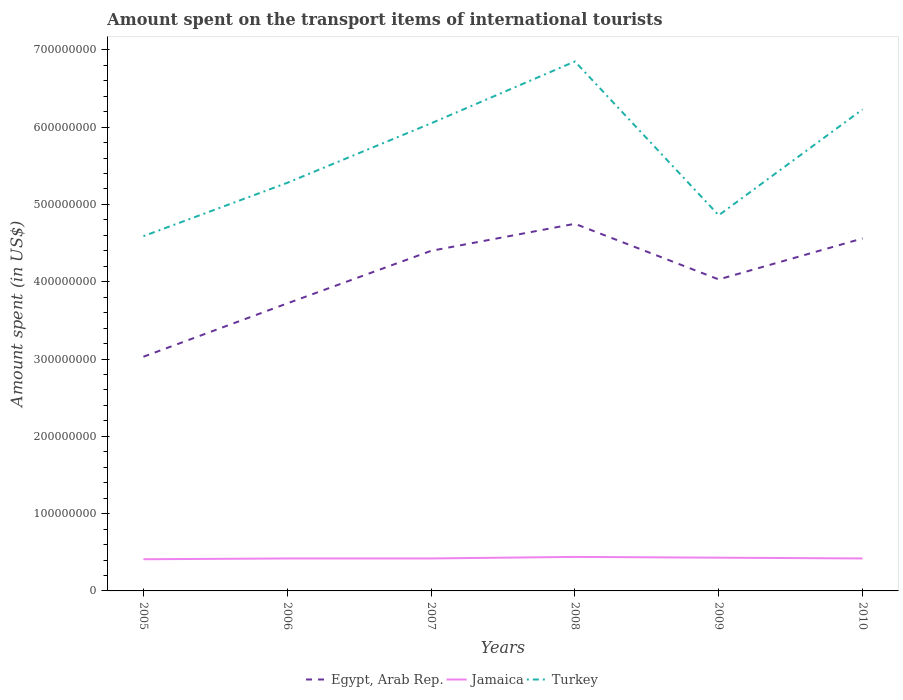How many different coloured lines are there?
Offer a terse response. 3. Across all years, what is the maximum amount spent on the transport items of international tourists in Jamaica?
Provide a succinct answer. 4.10e+07. In which year was the amount spent on the transport items of international tourists in Jamaica maximum?
Ensure brevity in your answer.  2005. What is the total amount spent on the transport items of international tourists in Jamaica in the graph?
Offer a terse response. 0. What is the difference between the highest and the second highest amount spent on the transport items of international tourists in Egypt, Arab Rep.?
Provide a succinct answer. 1.72e+08. What is the difference between the highest and the lowest amount spent on the transport items of international tourists in Egypt, Arab Rep.?
Your answer should be very brief. 3. How many years are there in the graph?
Make the answer very short. 6. What is the difference between two consecutive major ticks on the Y-axis?
Ensure brevity in your answer.  1.00e+08. Does the graph contain grids?
Your answer should be compact. No. How many legend labels are there?
Keep it short and to the point. 3. How are the legend labels stacked?
Keep it short and to the point. Horizontal. What is the title of the graph?
Ensure brevity in your answer.  Amount spent on the transport items of international tourists. What is the label or title of the X-axis?
Provide a succinct answer. Years. What is the label or title of the Y-axis?
Give a very brief answer. Amount spent (in US$). What is the Amount spent (in US$) of Egypt, Arab Rep. in 2005?
Keep it short and to the point. 3.03e+08. What is the Amount spent (in US$) of Jamaica in 2005?
Your answer should be very brief. 4.10e+07. What is the Amount spent (in US$) of Turkey in 2005?
Your answer should be very brief. 4.59e+08. What is the Amount spent (in US$) of Egypt, Arab Rep. in 2006?
Provide a succinct answer. 3.72e+08. What is the Amount spent (in US$) in Jamaica in 2006?
Make the answer very short. 4.20e+07. What is the Amount spent (in US$) of Turkey in 2006?
Make the answer very short. 5.28e+08. What is the Amount spent (in US$) of Egypt, Arab Rep. in 2007?
Provide a succinct answer. 4.40e+08. What is the Amount spent (in US$) in Jamaica in 2007?
Make the answer very short. 4.20e+07. What is the Amount spent (in US$) of Turkey in 2007?
Your response must be concise. 6.05e+08. What is the Amount spent (in US$) in Egypt, Arab Rep. in 2008?
Make the answer very short. 4.75e+08. What is the Amount spent (in US$) of Jamaica in 2008?
Your answer should be compact. 4.40e+07. What is the Amount spent (in US$) in Turkey in 2008?
Offer a very short reply. 6.85e+08. What is the Amount spent (in US$) of Egypt, Arab Rep. in 2009?
Give a very brief answer. 4.03e+08. What is the Amount spent (in US$) in Jamaica in 2009?
Your answer should be very brief. 4.30e+07. What is the Amount spent (in US$) in Turkey in 2009?
Provide a short and direct response. 4.86e+08. What is the Amount spent (in US$) of Egypt, Arab Rep. in 2010?
Give a very brief answer. 4.56e+08. What is the Amount spent (in US$) of Jamaica in 2010?
Offer a very short reply. 4.20e+07. What is the Amount spent (in US$) in Turkey in 2010?
Your answer should be very brief. 6.23e+08. Across all years, what is the maximum Amount spent (in US$) in Egypt, Arab Rep.?
Your answer should be compact. 4.75e+08. Across all years, what is the maximum Amount spent (in US$) in Jamaica?
Your answer should be compact. 4.40e+07. Across all years, what is the maximum Amount spent (in US$) of Turkey?
Ensure brevity in your answer.  6.85e+08. Across all years, what is the minimum Amount spent (in US$) in Egypt, Arab Rep.?
Your response must be concise. 3.03e+08. Across all years, what is the minimum Amount spent (in US$) of Jamaica?
Ensure brevity in your answer.  4.10e+07. Across all years, what is the minimum Amount spent (in US$) in Turkey?
Your answer should be very brief. 4.59e+08. What is the total Amount spent (in US$) of Egypt, Arab Rep. in the graph?
Offer a very short reply. 2.45e+09. What is the total Amount spent (in US$) of Jamaica in the graph?
Provide a short and direct response. 2.54e+08. What is the total Amount spent (in US$) of Turkey in the graph?
Provide a short and direct response. 3.39e+09. What is the difference between the Amount spent (in US$) of Egypt, Arab Rep. in 2005 and that in 2006?
Your response must be concise. -6.90e+07. What is the difference between the Amount spent (in US$) in Turkey in 2005 and that in 2006?
Give a very brief answer. -6.90e+07. What is the difference between the Amount spent (in US$) of Egypt, Arab Rep. in 2005 and that in 2007?
Provide a short and direct response. -1.37e+08. What is the difference between the Amount spent (in US$) in Turkey in 2005 and that in 2007?
Offer a very short reply. -1.46e+08. What is the difference between the Amount spent (in US$) in Egypt, Arab Rep. in 2005 and that in 2008?
Offer a very short reply. -1.72e+08. What is the difference between the Amount spent (in US$) in Turkey in 2005 and that in 2008?
Provide a succinct answer. -2.26e+08. What is the difference between the Amount spent (in US$) in Egypt, Arab Rep. in 2005 and that in 2009?
Ensure brevity in your answer.  -1.00e+08. What is the difference between the Amount spent (in US$) in Turkey in 2005 and that in 2009?
Make the answer very short. -2.70e+07. What is the difference between the Amount spent (in US$) of Egypt, Arab Rep. in 2005 and that in 2010?
Give a very brief answer. -1.53e+08. What is the difference between the Amount spent (in US$) of Turkey in 2005 and that in 2010?
Your answer should be very brief. -1.64e+08. What is the difference between the Amount spent (in US$) in Egypt, Arab Rep. in 2006 and that in 2007?
Keep it short and to the point. -6.80e+07. What is the difference between the Amount spent (in US$) of Turkey in 2006 and that in 2007?
Ensure brevity in your answer.  -7.70e+07. What is the difference between the Amount spent (in US$) of Egypt, Arab Rep. in 2006 and that in 2008?
Offer a terse response. -1.03e+08. What is the difference between the Amount spent (in US$) of Jamaica in 2006 and that in 2008?
Provide a succinct answer. -2.00e+06. What is the difference between the Amount spent (in US$) in Turkey in 2006 and that in 2008?
Offer a very short reply. -1.57e+08. What is the difference between the Amount spent (in US$) in Egypt, Arab Rep. in 2006 and that in 2009?
Offer a very short reply. -3.10e+07. What is the difference between the Amount spent (in US$) of Turkey in 2006 and that in 2009?
Your answer should be compact. 4.20e+07. What is the difference between the Amount spent (in US$) in Egypt, Arab Rep. in 2006 and that in 2010?
Offer a very short reply. -8.40e+07. What is the difference between the Amount spent (in US$) in Jamaica in 2006 and that in 2010?
Your answer should be very brief. 0. What is the difference between the Amount spent (in US$) in Turkey in 2006 and that in 2010?
Provide a succinct answer. -9.50e+07. What is the difference between the Amount spent (in US$) of Egypt, Arab Rep. in 2007 and that in 2008?
Ensure brevity in your answer.  -3.50e+07. What is the difference between the Amount spent (in US$) of Turkey in 2007 and that in 2008?
Ensure brevity in your answer.  -8.00e+07. What is the difference between the Amount spent (in US$) of Egypt, Arab Rep. in 2007 and that in 2009?
Provide a short and direct response. 3.70e+07. What is the difference between the Amount spent (in US$) in Jamaica in 2007 and that in 2009?
Give a very brief answer. -1.00e+06. What is the difference between the Amount spent (in US$) of Turkey in 2007 and that in 2009?
Offer a terse response. 1.19e+08. What is the difference between the Amount spent (in US$) in Egypt, Arab Rep. in 2007 and that in 2010?
Keep it short and to the point. -1.60e+07. What is the difference between the Amount spent (in US$) of Jamaica in 2007 and that in 2010?
Your response must be concise. 0. What is the difference between the Amount spent (in US$) in Turkey in 2007 and that in 2010?
Your answer should be very brief. -1.80e+07. What is the difference between the Amount spent (in US$) of Egypt, Arab Rep. in 2008 and that in 2009?
Your answer should be very brief. 7.20e+07. What is the difference between the Amount spent (in US$) in Turkey in 2008 and that in 2009?
Ensure brevity in your answer.  1.99e+08. What is the difference between the Amount spent (in US$) of Egypt, Arab Rep. in 2008 and that in 2010?
Offer a very short reply. 1.90e+07. What is the difference between the Amount spent (in US$) of Jamaica in 2008 and that in 2010?
Your answer should be very brief. 2.00e+06. What is the difference between the Amount spent (in US$) in Turkey in 2008 and that in 2010?
Give a very brief answer. 6.20e+07. What is the difference between the Amount spent (in US$) of Egypt, Arab Rep. in 2009 and that in 2010?
Offer a very short reply. -5.30e+07. What is the difference between the Amount spent (in US$) of Turkey in 2009 and that in 2010?
Provide a succinct answer. -1.37e+08. What is the difference between the Amount spent (in US$) of Egypt, Arab Rep. in 2005 and the Amount spent (in US$) of Jamaica in 2006?
Keep it short and to the point. 2.61e+08. What is the difference between the Amount spent (in US$) in Egypt, Arab Rep. in 2005 and the Amount spent (in US$) in Turkey in 2006?
Offer a terse response. -2.25e+08. What is the difference between the Amount spent (in US$) of Jamaica in 2005 and the Amount spent (in US$) of Turkey in 2006?
Your response must be concise. -4.87e+08. What is the difference between the Amount spent (in US$) in Egypt, Arab Rep. in 2005 and the Amount spent (in US$) in Jamaica in 2007?
Offer a very short reply. 2.61e+08. What is the difference between the Amount spent (in US$) of Egypt, Arab Rep. in 2005 and the Amount spent (in US$) of Turkey in 2007?
Your response must be concise. -3.02e+08. What is the difference between the Amount spent (in US$) in Jamaica in 2005 and the Amount spent (in US$) in Turkey in 2007?
Your answer should be very brief. -5.64e+08. What is the difference between the Amount spent (in US$) of Egypt, Arab Rep. in 2005 and the Amount spent (in US$) of Jamaica in 2008?
Your answer should be very brief. 2.59e+08. What is the difference between the Amount spent (in US$) in Egypt, Arab Rep. in 2005 and the Amount spent (in US$) in Turkey in 2008?
Provide a succinct answer. -3.82e+08. What is the difference between the Amount spent (in US$) of Jamaica in 2005 and the Amount spent (in US$) of Turkey in 2008?
Give a very brief answer. -6.44e+08. What is the difference between the Amount spent (in US$) of Egypt, Arab Rep. in 2005 and the Amount spent (in US$) of Jamaica in 2009?
Offer a terse response. 2.60e+08. What is the difference between the Amount spent (in US$) of Egypt, Arab Rep. in 2005 and the Amount spent (in US$) of Turkey in 2009?
Ensure brevity in your answer.  -1.83e+08. What is the difference between the Amount spent (in US$) of Jamaica in 2005 and the Amount spent (in US$) of Turkey in 2009?
Make the answer very short. -4.45e+08. What is the difference between the Amount spent (in US$) of Egypt, Arab Rep. in 2005 and the Amount spent (in US$) of Jamaica in 2010?
Your answer should be compact. 2.61e+08. What is the difference between the Amount spent (in US$) in Egypt, Arab Rep. in 2005 and the Amount spent (in US$) in Turkey in 2010?
Provide a succinct answer. -3.20e+08. What is the difference between the Amount spent (in US$) of Jamaica in 2005 and the Amount spent (in US$) of Turkey in 2010?
Offer a terse response. -5.82e+08. What is the difference between the Amount spent (in US$) in Egypt, Arab Rep. in 2006 and the Amount spent (in US$) in Jamaica in 2007?
Provide a short and direct response. 3.30e+08. What is the difference between the Amount spent (in US$) of Egypt, Arab Rep. in 2006 and the Amount spent (in US$) of Turkey in 2007?
Your answer should be compact. -2.33e+08. What is the difference between the Amount spent (in US$) of Jamaica in 2006 and the Amount spent (in US$) of Turkey in 2007?
Provide a short and direct response. -5.63e+08. What is the difference between the Amount spent (in US$) in Egypt, Arab Rep. in 2006 and the Amount spent (in US$) in Jamaica in 2008?
Give a very brief answer. 3.28e+08. What is the difference between the Amount spent (in US$) of Egypt, Arab Rep. in 2006 and the Amount spent (in US$) of Turkey in 2008?
Offer a terse response. -3.13e+08. What is the difference between the Amount spent (in US$) of Jamaica in 2006 and the Amount spent (in US$) of Turkey in 2008?
Provide a short and direct response. -6.43e+08. What is the difference between the Amount spent (in US$) in Egypt, Arab Rep. in 2006 and the Amount spent (in US$) in Jamaica in 2009?
Offer a very short reply. 3.29e+08. What is the difference between the Amount spent (in US$) of Egypt, Arab Rep. in 2006 and the Amount spent (in US$) of Turkey in 2009?
Ensure brevity in your answer.  -1.14e+08. What is the difference between the Amount spent (in US$) in Jamaica in 2006 and the Amount spent (in US$) in Turkey in 2009?
Your response must be concise. -4.44e+08. What is the difference between the Amount spent (in US$) in Egypt, Arab Rep. in 2006 and the Amount spent (in US$) in Jamaica in 2010?
Keep it short and to the point. 3.30e+08. What is the difference between the Amount spent (in US$) of Egypt, Arab Rep. in 2006 and the Amount spent (in US$) of Turkey in 2010?
Provide a succinct answer. -2.51e+08. What is the difference between the Amount spent (in US$) in Jamaica in 2006 and the Amount spent (in US$) in Turkey in 2010?
Your answer should be compact. -5.81e+08. What is the difference between the Amount spent (in US$) in Egypt, Arab Rep. in 2007 and the Amount spent (in US$) in Jamaica in 2008?
Your answer should be compact. 3.96e+08. What is the difference between the Amount spent (in US$) in Egypt, Arab Rep. in 2007 and the Amount spent (in US$) in Turkey in 2008?
Your response must be concise. -2.45e+08. What is the difference between the Amount spent (in US$) in Jamaica in 2007 and the Amount spent (in US$) in Turkey in 2008?
Offer a very short reply. -6.43e+08. What is the difference between the Amount spent (in US$) in Egypt, Arab Rep. in 2007 and the Amount spent (in US$) in Jamaica in 2009?
Give a very brief answer. 3.97e+08. What is the difference between the Amount spent (in US$) in Egypt, Arab Rep. in 2007 and the Amount spent (in US$) in Turkey in 2009?
Offer a very short reply. -4.60e+07. What is the difference between the Amount spent (in US$) in Jamaica in 2007 and the Amount spent (in US$) in Turkey in 2009?
Your answer should be very brief. -4.44e+08. What is the difference between the Amount spent (in US$) of Egypt, Arab Rep. in 2007 and the Amount spent (in US$) of Jamaica in 2010?
Make the answer very short. 3.98e+08. What is the difference between the Amount spent (in US$) of Egypt, Arab Rep. in 2007 and the Amount spent (in US$) of Turkey in 2010?
Make the answer very short. -1.83e+08. What is the difference between the Amount spent (in US$) in Jamaica in 2007 and the Amount spent (in US$) in Turkey in 2010?
Your response must be concise. -5.81e+08. What is the difference between the Amount spent (in US$) of Egypt, Arab Rep. in 2008 and the Amount spent (in US$) of Jamaica in 2009?
Provide a short and direct response. 4.32e+08. What is the difference between the Amount spent (in US$) in Egypt, Arab Rep. in 2008 and the Amount spent (in US$) in Turkey in 2009?
Make the answer very short. -1.10e+07. What is the difference between the Amount spent (in US$) in Jamaica in 2008 and the Amount spent (in US$) in Turkey in 2009?
Make the answer very short. -4.42e+08. What is the difference between the Amount spent (in US$) of Egypt, Arab Rep. in 2008 and the Amount spent (in US$) of Jamaica in 2010?
Provide a short and direct response. 4.33e+08. What is the difference between the Amount spent (in US$) in Egypt, Arab Rep. in 2008 and the Amount spent (in US$) in Turkey in 2010?
Give a very brief answer. -1.48e+08. What is the difference between the Amount spent (in US$) in Jamaica in 2008 and the Amount spent (in US$) in Turkey in 2010?
Provide a succinct answer. -5.79e+08. What is the difference between the Amount spent (in US$) in Egypt, Arab Rep. in 2009 and the Amount spent (in US$) in Jamaica in 2010?
Make the answer very short. 3.61e+08. What is the difference between the Amount spent (in US$) of Egypt, Arab Rep. in 2009 and the Amount spent (in US$) of Turkey in 2010?
Your answer should be very brief. -2.20e+08. What is the difference between the Amount spent (in US$) in Jamaica in 2009 and the Amount spent (in US$) in Turkey in 2010?
Your answer should be very brief. -5.80e+08. What is the average Amount spent (in US$) of Egypt, Arab Rep. per year?
Provide a succinct answer. 4.08e+08. What is the average Amount spent (in US$) of Jamaica per year?
Your answer should be compact. 4.23e+07. What is the average Amount spent (in US$) in Turkey per year?
Offer a terse response. 5.64e+08. In the year 2005, what is the difference between the Amount spent (in US$) of Egypt, Arab Rep. and Amount spent (in US$) of Jamaica?
Keep it short and to the point. 2.62e+08. In the year 2005, what is the difference between the Amount spent (in US$) of Egypt, Arab Rep. and Amount spent (in US$) of Turkey?
Provide a succinct answer. -1.56e+08. In the year 2005, what is the difference between the Amount spent (in US$) of Jamaica and Amount spent (in US$) of Turkey?
Give a very brief answer. -4.18e+08. In the year 2006, what is the difference between the Amount spent (in US$) in Egypt, Arab Rep. and Amount spent (in US$) in Jamaica?
Provide a succinct answer. 3.30e+08. In the year 2006, what is the difference between the Amount spent (in US$) of Egypt, Arab Rep. and Amount spent (in US$) of Turkey?
Your answer should be very brief. -1.56e+08. In the year 2006, what is the difference between the Amount spent (in US$) in Jamaica and Amount spent (in US$) in Turkey?
Offer a terse response. -4.86e+08. In the year 2007, what is the difference between the Amount spent (in US$) of Egypt, Arab Rep. and Amount spent (in US$) of Jamaica?
Your answer should be compact. 3.98e+08. In the year 2007, what is the difference between the Amount spent (in US$) of Egypt, Arab Rep. and Amount spent (in US$) of Turkey?
Provide a succinct answer. -1.65e+08. In the year 2007, what is the difference between the Amount spent (in US$) of Jamaica and Amount spent (in US$) of Turkey?
Provide a succinct answer. -5.63e+08. In the year 2008, what is the difference between the Amount spent (in US$) of Egypt, Arab Rep. and Amount spent (in US$) of Jamaica?
Ensure brevity in your answer.  4.31e+08. In the year 2008, what is the difference between the Amount spent (in US$) in Egypt, Arab Rep. and Amount spent (in US$) in Turkey?
Make the answer very short. -2.10e+08. In the year 2008, what is the difference between the Amount spent (in US$) of Jamaica and Amount spent (in US$) of Turkey?
Provide a succinct answer. -6.41e+08. In the year 2009, what is the difference between the Amount spent (in US$) in Egypt, Arab Rep. and Amount spent (in US$) in Jamaica?
Your response must be concise. 3.60e+08. In the year 2009, what is the difference between the Amount spent (in US$) of Egypt, Arab Rep. and Amount spent (in US$) of Turkey?
Offer a terse response. -8.30e+07. In the year 2009, what is the difference between the Amount spent (in US$) in Jamaica and Amount spent (in US$) in Turkey?
Make the answer very short. -4.43e+08. In the year 2010, what is the difference between the Amount spent (in US$) in Egypt, Arab Rep. and Amount spent (in US$) in Jamaica?
Give a very brief answer. 4.14e+08. In the year 2010, what is the difference between the Amount spent (in US$) of Egypt, Arab Rep. and Amount spent (in US$) of Turkey?
Ensure brevity in your answer.  -1.67e+08. In the year 2010, what is the difference between the Amount spent (in US$) in Jamaica and Amount spent (in US$) in Turkey?
Your answer should be compact. -5.81e+08. What is the ratio of the Amount spent (in US$) in Egypt, Arab Rep. in 2005 to that in 2006?
Your answer should be very brief. 0.81. What is the ratio of the Amount spent (in US$) of Jamaica in 2005 to that in 2006?
Provide a succinct answer. 0.98. What is the ratio of the Amount spent (in US$) of Turkey in 2005 to that in 2006?
Your answer should be compact. 0.87. What is the ratio of the Amount spent (in US$) of Egypt, Arab Rep. in 2005 to that in 2007?
Provide a short and direct response. 0.69. What is the ratio of the Amount spent (in US$) in Jamaica in 2005 to that in 2007?
Your answer should be very brief. 0.98. What is the ratio of the Amount spent (in US$) in Turkey in 2005 to that in 2007?
Keep it short and to the point. 0.76. What is the ratio of the Amount spent (in US$) of Egypt, Arab Rep. in 2005 to that in 2008?
Offer a terse response. 0.64. What is the ratio of the Amount spent (in US$) of Jamaica in 2005 to that in 2008?
Your answer should be very brief. 0.93. What is the ratio of the Amount spent (in US$) in Turkey in 2005 to that in 2008?
Provide a short and direct response. 0.67. What is the ratio of the Amount spent (in US$) of Egypt, Arab Rep. in 2005 to that in 2009?
Offer a very short reply. 0.75. What is the ratio of the Amount spent (in US$) in Jamaica in 2005 to that in 2009?
Offer a terse response. 0.95. What is the ratio of the Amount spent (in US$) of Egypt, Arab Rep. in 2005 to that in 2010?
Ensure brevity in your answer.  0.66. What is the ratio of the Amount spent (in US$) of Jamaica in 2005 to that in 2010?
Provide a short and direct response. 0.98. What is the ratio of the Amount spent (in US$) of Turkey in 2005 to that in 2010?
Offer a very short reply. 0.74. What is the ratio of the Amount spent (in US$) of Egypt, Arab Rep. in 2006 to that in 2007?
Your answer should be very brief. 0.85. What is the ratio of the Amount spent (in US$) in Turkey in 2006 to that in 2007?
Your answer should be compact. 0.87. What is the ratio of the Amount spent (in US$) of Egypt, Arab Rep. in 2006 to that in 2008?
Give a very brief answer. 0.78. What is the ratio of the Amount spent (in US$) in Jamaica in 2006 to that in 2008?
Give a very brief answer. 0.95. What is the ratio of the Amount spent (in US$) of Turkey in 2006 to that in 2008?
Provide a short and direct response. 0.77. What is the ratio of the Amount spent (in US$) of Jamaica in 2006 to that in 2009?
Ensure brevity in your answer.  0.98. What is the ratio of the Amount spent (in US$) in Turkey in 2006 to that in 2009?
Give a very brief answer. 1.09. What is the ratio of the Amount spent (in US$) of Egypt, Arab Rep. in 2006 to that in 2010?
Ensure brevity in your answer.  0.82. What is the ratio of the Amount spent (in US$) in Jamaica in 2006 to that in 2010?
Your answer should be very brief. 1. What is the ratio of the Amount spent (in US$) of Turkey in 2006 to that in 2010?
Offer a very short reply. 0.85. What is the ratio of the Amount spent (in US$) in Egypt, Arab Rep. in 2007 to that in 2008?
Your response must be concise. 0.93. What is the ratio of the Amount spent (in US$) of Jamaica in 2007 to that in 2008?
Ensure brevity in your answer.  0.95. What is the ratio of the Amount spent (in US$) in Turkey in 2007 to that in 2008?
Provide a short and direct response. 0.88. What is the ratio of the Amount spent (in US$) of Egypt, Arab Rep. in 2007 to that in 2009?
Your answer should be very brief. 1.09. What is the ratio of the Amount spent (in US$) in Jamaica in 2007 to that in 2009?
Keep it short and to the point. 0.98. What is the ratio of the Amount spent (in US$) in Turkey in 2007 to that in 2009?
Keep it short and to the point. 1.24. What is the ratio of the Amount spent (in US$) in Egypt, Arab Rep. in 2007 to that in 2010?
Offer a terse response. 0.96. What is the ratio of the Amount spent (in US$) of Turkey in 2007 to that in 2010?
Your answer should be very brief. 0.97. What is the ratio of the Amount spent (in US$) of Egypt, Arab Rep. in 2008 to that in 2009?
Make the answer very short. 1.18. What is the ratio of the Amount spent (in US$) in Jamaica in 2008 to that in 2009?
Offer a very short reply. 1.02. What is the ratio of the Amount spent (in US$) in Turkey in 2008 to that in 2009?
Keep it short and to the point. 1.41. What is the ratio of the Amount spent (in US$) of Egypt, Arab Rep. in 2008 to that in 2010?
Give a very brief answer. 1.04. What is the ratio of the Amount spent (in US$) of Jamaica in 2008 to that in 2010?
Provide a short and direct response. 1.05. What is the ratio of the Amount spent (in US$) of Turkey in 2008 to that in 2010?
Your response must be concise. 1.1. What is the ratio of the Amount spent (in US$) in Egypt, Arab Rep. in 2009 to that in 2010?
Ensure brevity in your answer.  0.88. What is the ratio of the Amount spent (in US$) in Jamaica in 2009 to that in 2010?
Offer a very short reply. 1.02. What is the ratio of the Amount spent (in US$) in Turkey in 2009 to that in 2010?
Offer a terse response. 0.78. What is the difference between the highest and the second highest Amount spent (in US$) of Egypt, Arab Rep.?
Ensure brevity in your answer.  1.90e+07. What is the difference between the highest and the second highest Amount spent (in US$) of Jamaica?
Give a very brief answer. 1.00e+06. What is the difference between the highest and the second highest Amount spent (in US$) of Turkey?
Make the answer very short. 6.20e+07. What is the difference between the highest and the lowest Amount spent (in US$) in Egypt, Arab Rep.?
Make the answer very short. 1.72e+08. What is the difference between the highest and the lowest Amount spent (in US$) in Jamaica?
Your answer should be compact. 3.00e+06. What is the difference between the highest and the lowest Amount spent (in US$) of Turkey?
Offer a terse response. 2.26e+08. 